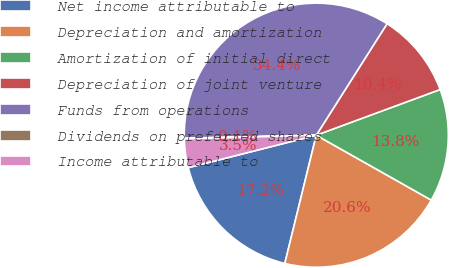Convert chart to OTSL. <chart><loc_0><loc_0><loc_500><loc_500><pie_chart><fcel>Net income attributable to<fcel>Depreciation and amortization<fcel>Amortization of initial direct<fcel>Depreciation of joint venture<fcel>Funds from operations<fcel>Dividends on preferred shares<fcel>Income attributable to<nl><fcel>17.22%<fcel>20.65%<fcel>13.8%<fcel>10.37%<fcel>34.37%<fcel>0.08%<fcel>3.51%<nl></chart> 